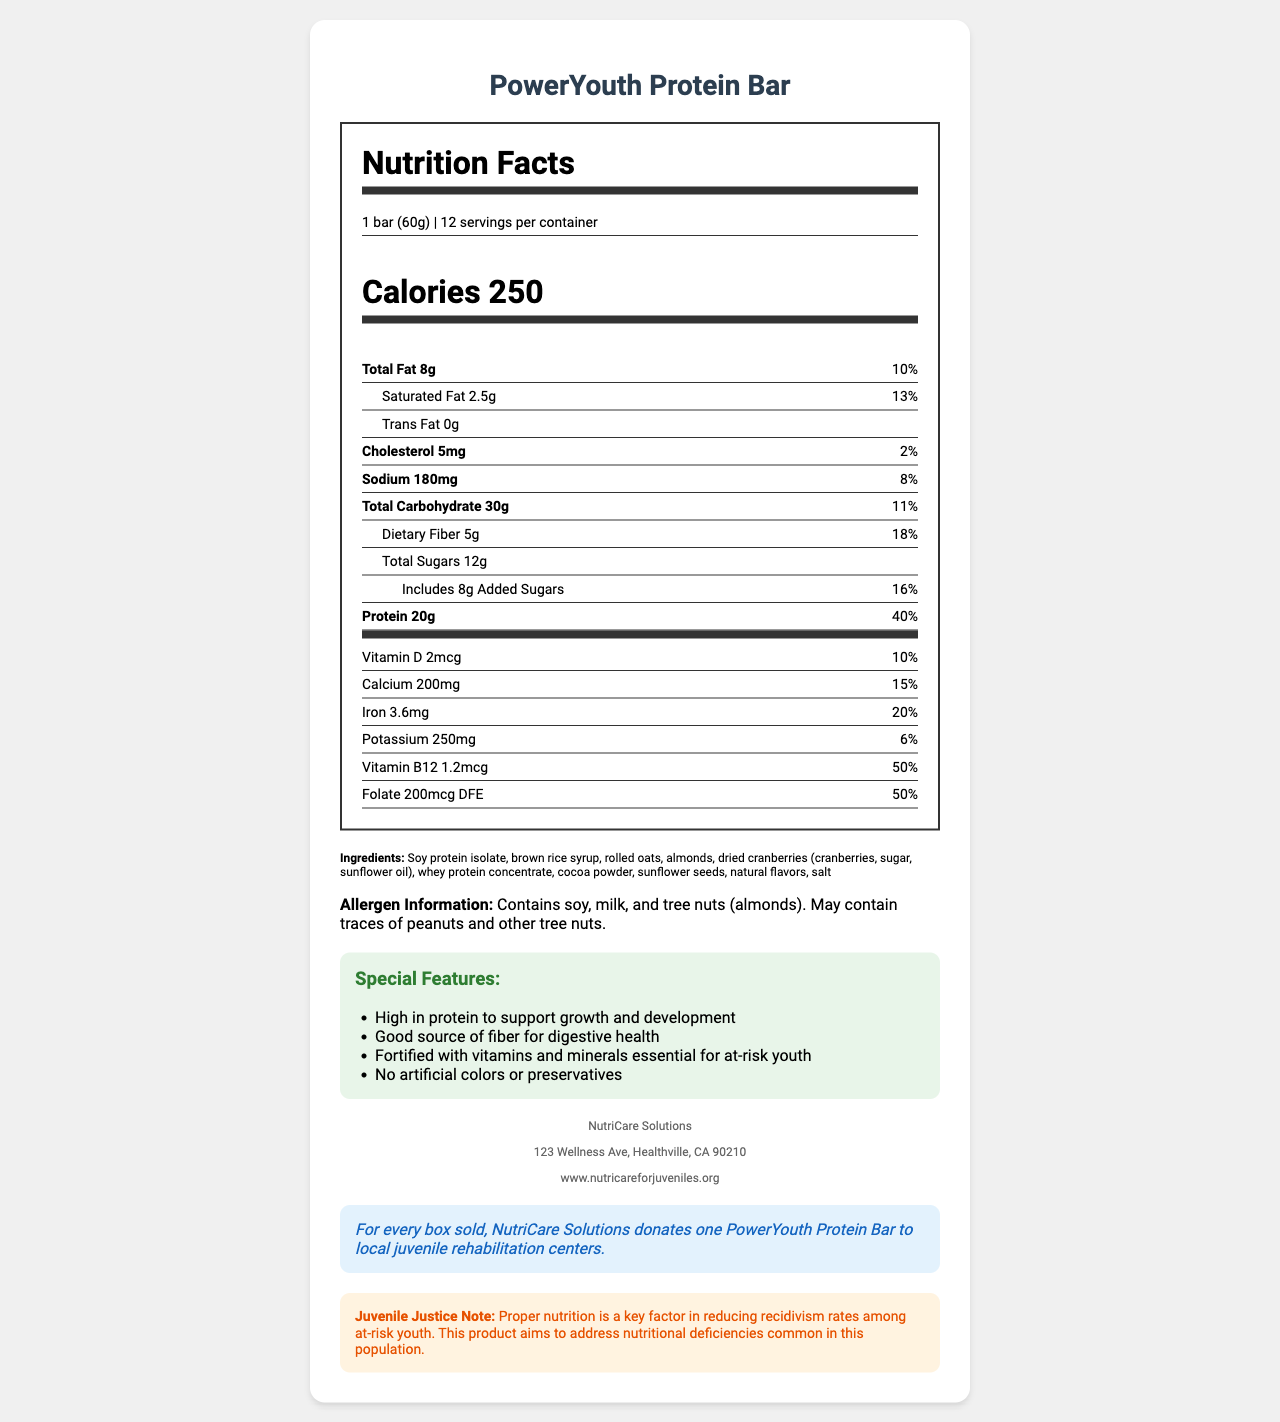what is the serving size of the PowerYouth Protein Bar? The serving size is listed as "1 bar (60g)" in the nutrition label.
Answer: 1 bar (60g) how many calories does each serving contain? Each serving contains 250 calories as stated in the nutrition facts section.
Answer: 250 what is the total fat content per bar? The total fat content per bar is given as 8g.
Answer: 8g how much dietary fiber is in one serving of the PowerYouth Protein Bar? The nutrition facts show that one serving contains 5g of dietary fiber.
Answer: 5g what is the percent daily value of protein in the PowerYouth Protein Bar? The percent daily value of protein is stated to be 40%.
Answer: 40% what allergens are present in the PowerYouth Protein Bar? A. Peanuts, soy, dairy B. Soy, milk, tree nuts C. Wheat, dairy, soy The allergen statement indicates the product contains soy, milk, and tree nuts (almonds).
Answer: B. Soy, milk, tree nuts which vitamin has the highest percent daily value in the PowerYouth Protein Bar? A. Vitamin D B. Calcium C. Vitamin B12 Vitamin B12 has the highest percent daily value listed at 50%.
Answer: C. Vitamin B12 does the PowerYouth Protein Bar contain any trans fat? The nutrition label specifies that the trans fat content is 0g.
Answer: No summarize the main features and purpose of the PowerYouth Protein Bar. The document details the nutritional content, ingredients, special features, and social impact statement of the PowerYouth Protein Bar, alongside a note on its relevance to juvenile justice.
Answer: The PowerYouth Protein Bar is a high-protein meal replacement designed for at-risk youth. It is high in protein, a good source of fiber, and fortified with essential vitamins and minerals. The product contains no artificial colors or preservatives and is distributed by NutriCare Solutions, which donates one bar to juvenile rehabilitation centers for each box sold. The bar aims to address nutritional deficiencies to reduce recidivism rates among at-risk youth. where is NutriCare Solutions located? The manufacturer information section lists the address of NutriCare Solutions.
Answer: 123 Wellness Ave, Healthville, CA 90210 how much added sugar is in the PowerYouth Protein Bar? The nutrition label specifies that there are 8g of added sugars.
Answer: 8g how many servings are there in each container? The container holds 12 servings, as specified in the nutrition facts.
Answer: 12 does the PowerYouth Protein Bar contain any artificial colors or preservatives? The special features note that the bar contains no artificial colors or preservatives.
Answer: No what is the role of proper nutrition according to the juvenile justice note? The juvenile justice note mentions that proper nutrition is important for reducing recidivism rates in at-risk youth.
Answer: It is a key factor in reducing recidivism rates among at-risk youth. what is the manufacturer's name? The manufacturer information section lists the name as NutriCare Solutions.
Answer: NutriCare Solutions what is the website for NutriCare Solutions? The manufacturer information section lists the website as www.nutricareforjuveniles.org.
Answer: www.nutricareforjuveniles.org how much calcium is in the PowerYouth Protein Bar per serving? The nutrition label specifies that each serving contains 200mg of calcium.
Answer: 200mg how many grams of saturated fat does the PowerYouth Protein Bar contain? The nutrition facts specify that each bar contains 2.5g of saturated fat.
Answer: 2.5g what specific impact does NutriCare Solutions aim for with their donation program? The social impact statement explains that the donation program involves donating one bar for each box sold to local juvenile rehabilitation centers.
Answer: Donates one PowerYouth Protein Bar to local juvenile rehabilitation centers for each box sold. how does the PowerYouth Protein Bar support digestive health? The special features mention that the bar is a good source of fiber, which supports digestive health.
Answer: It is a good source of fiber. how many vitamins and minerals are listed in the PowerYouth Protein Bar? The nutrition label lists six vitamins and minerals: Vitamin D, Calcium, Iron, Potassium, Vitamin B12, and Folate.
Answer: 6 what is the role of folate in the PowerYouth Protein Bar? The nutrition label indicates that folate provides 50% of the daily value.
Answer: It provides 50% of the daily value 